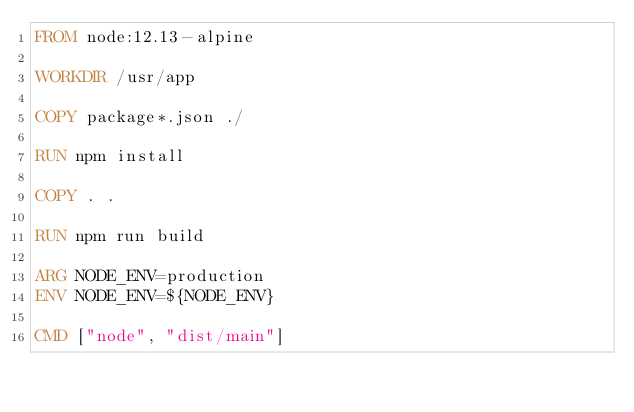Convert code to text. <code><loc_0><loc_0><loc_500><loc_500><_Dockerfile_>FROM node:12.13-alpine

WORKDIR /usr/app

COPY package*.json ./

RUN npm install 

COPY . .

RUN npm run build

ARG NODE_ENV=production
ENV NODE_ENV=${NODE_ENV}

CMD ["node", "dist/main"]
</code> 